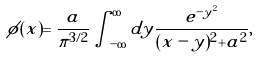Convert formula to latex. <formula><loc_0><loc_0><loc_500><loc_500>\phi ( x ) = \frac { a } { \pi ^ { 3 / 2 } } \int _ { - \infty } ^ { \infty } d y \frac { e ^ { - y ^ { 2 } } } { ( x - y ) ^ { 2 } + a ^ { 2 } } ,</formula> 